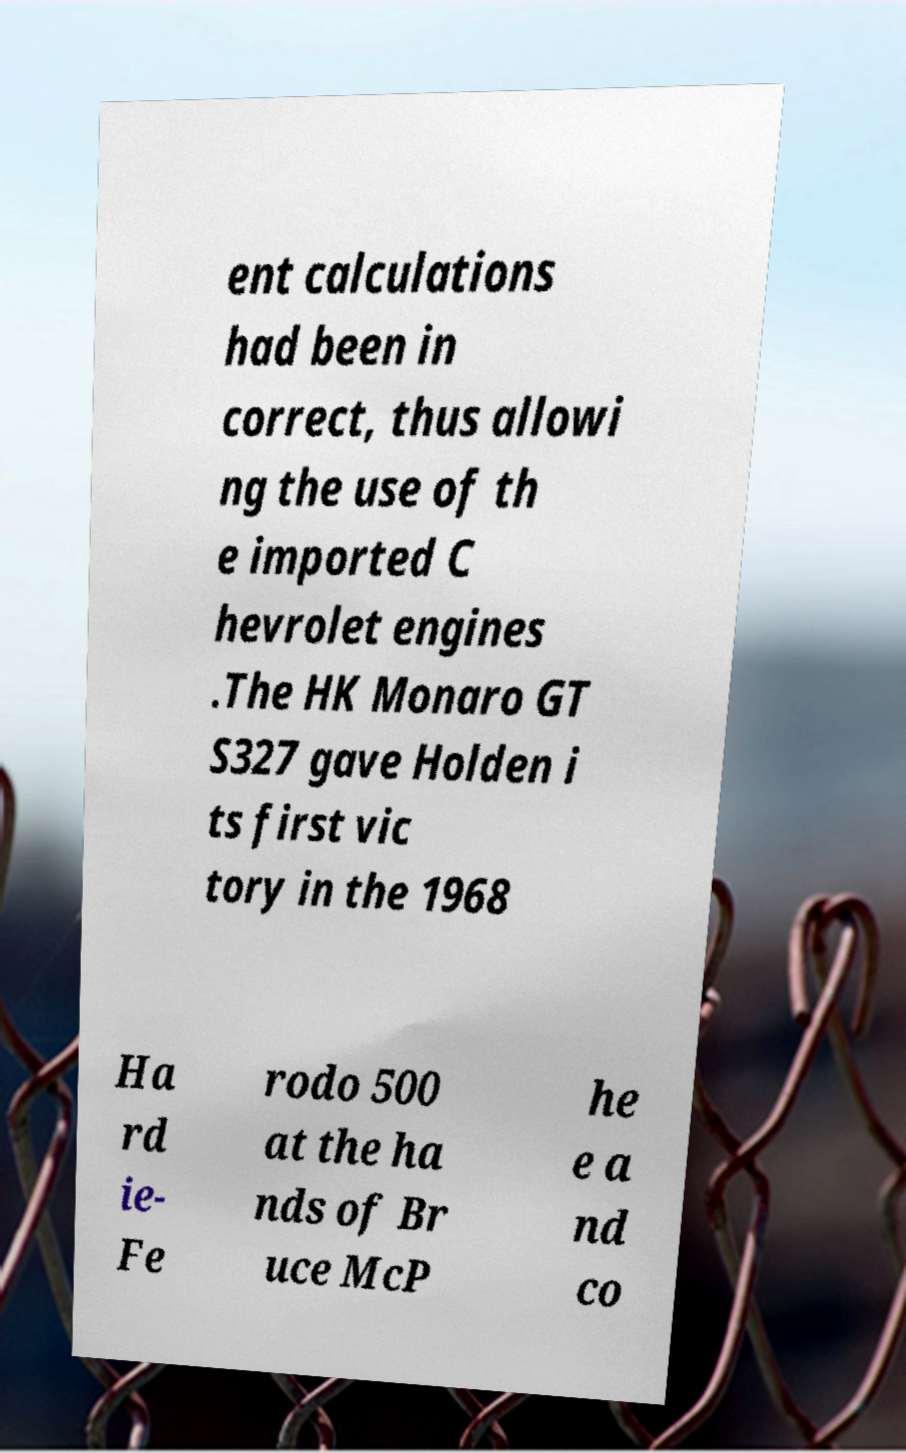Can you accurately transcribe the text from the provided image for me? ent calculations had been in correct, thus allowi ng the use of th e imported C hevrolet engines .The HK Monaro GT S327 gave Holden i ts first vic tory in the 1968 Ha rd ie- Fe rodo 500 at the ha nds of Br uce McP he e a nd co 